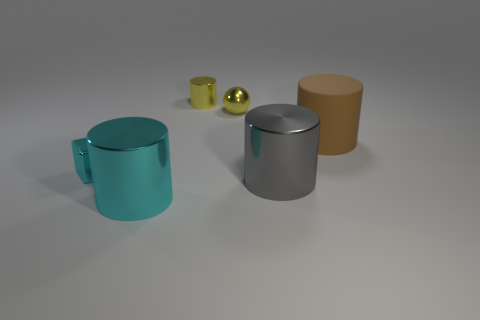Subtract 2 cylinders. How many cylinders are left? 2 Subtract all yellow metallic cylinders. How many cylinders are left? 3 Subtract all gray cylinders. How many cylinders are left? 3 Add 1 yellow things. How many objects exist? 7 Subtract all blue cylinders. Subtract all blue cubes. How many cylinders are left? 4 Subtract all cubes. How many objects are left? 5 Subtract all tiny purple rubber cylinders. Subtract all small cubes. How many objects are left? 5 Add 1 small cubes. How many small cubes are left? 2 Add 4 large brown cylinders. How many large brown cylinders exist? 5 Subtract 1 cyan cylinders. How many objects are left? 5 